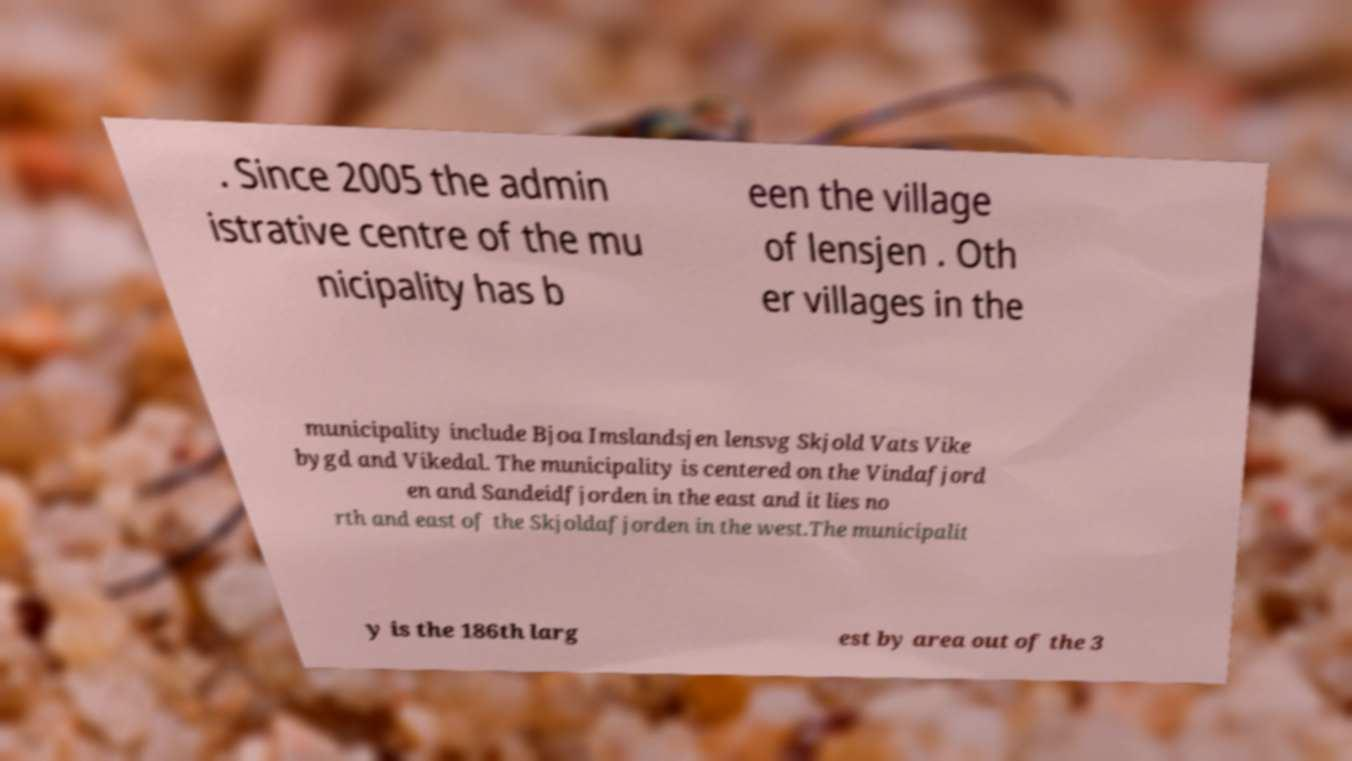For documentation purposes, I need the text within this image transcribed. Could you provide that? . Since 2005 the admin istrative centre of the mu nicipality has b een the village of lensjen . Oth er villages in the municipality include Bjoa Imslandsjen lensvg Skjold Vats Vike bygd and Vikedal. The municipality is centered on the Vindafjord en and Sandeidfjorden in the east and it lies no rth and east of the Skjoldafjorden in the west.The municipalit y is the 186th larg est by area out of the 3 